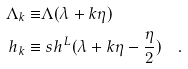Convert formula to latex. <formula><loc_0><loc_0><loc_500><loc_500>\Lambda _ { k } \equiv & \Lambda ( \lambda + k \eta ) \\ h _ { k } \equiv & \ s h ^ { L } ( \lambda + k \eta - \frac { \eta } { 2 } ) \quad .</formula> 